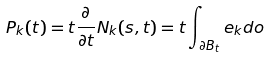<formula> <loc_0><loc_0><loc_500><loc_500>P _ { k } ( t ) = t \frac { \partial } { \partial t } N _ { k } ( s , t ) = t \int _ { \partial B _ { t } } e _ { k } d o</formula> 